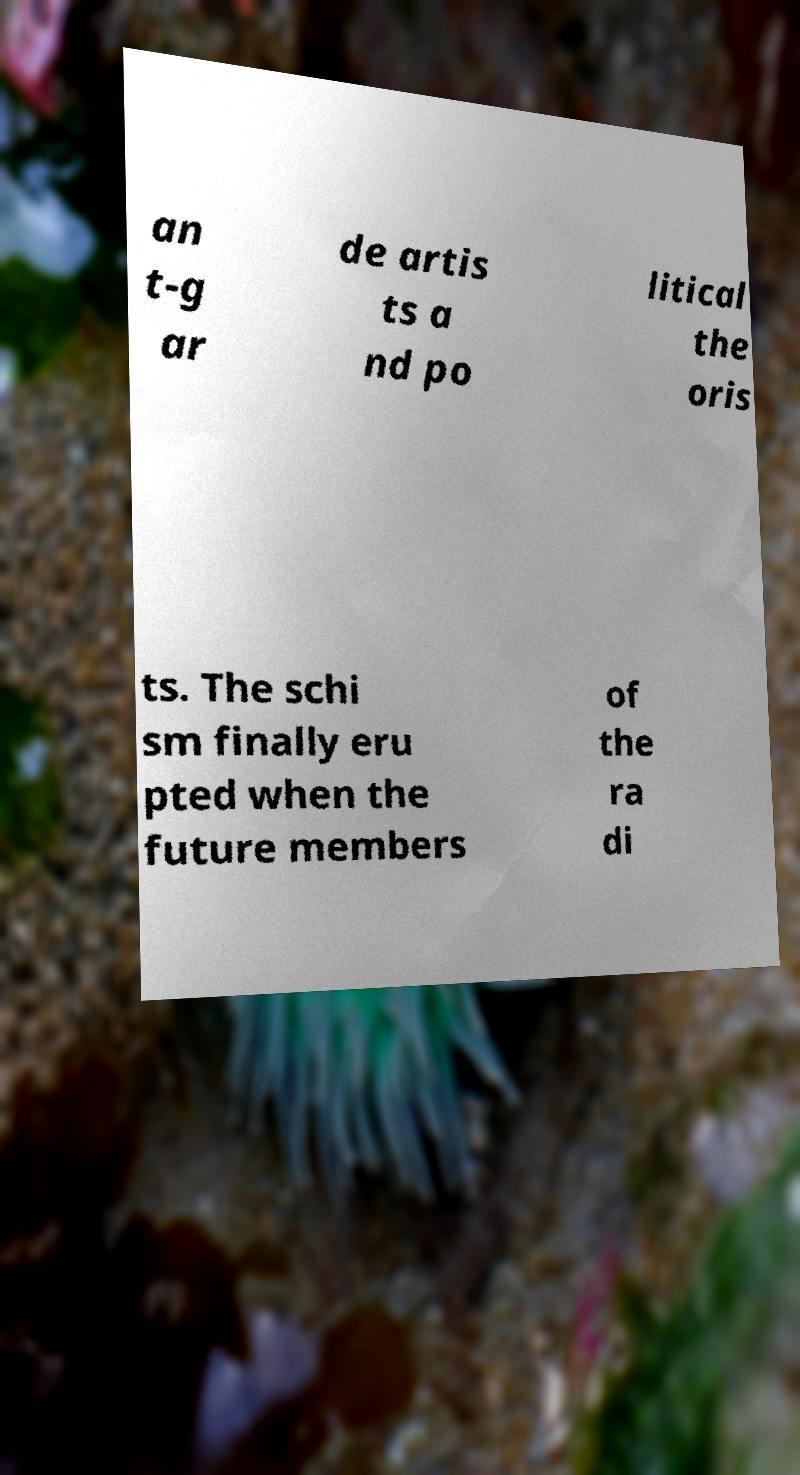There's text embedded in this image that I need extracted. Can you transcribe it verbatim? an t-g ar de artis ts a nd po litical the oris ts. The schi sm finally eru pted when the future members of the ra di 